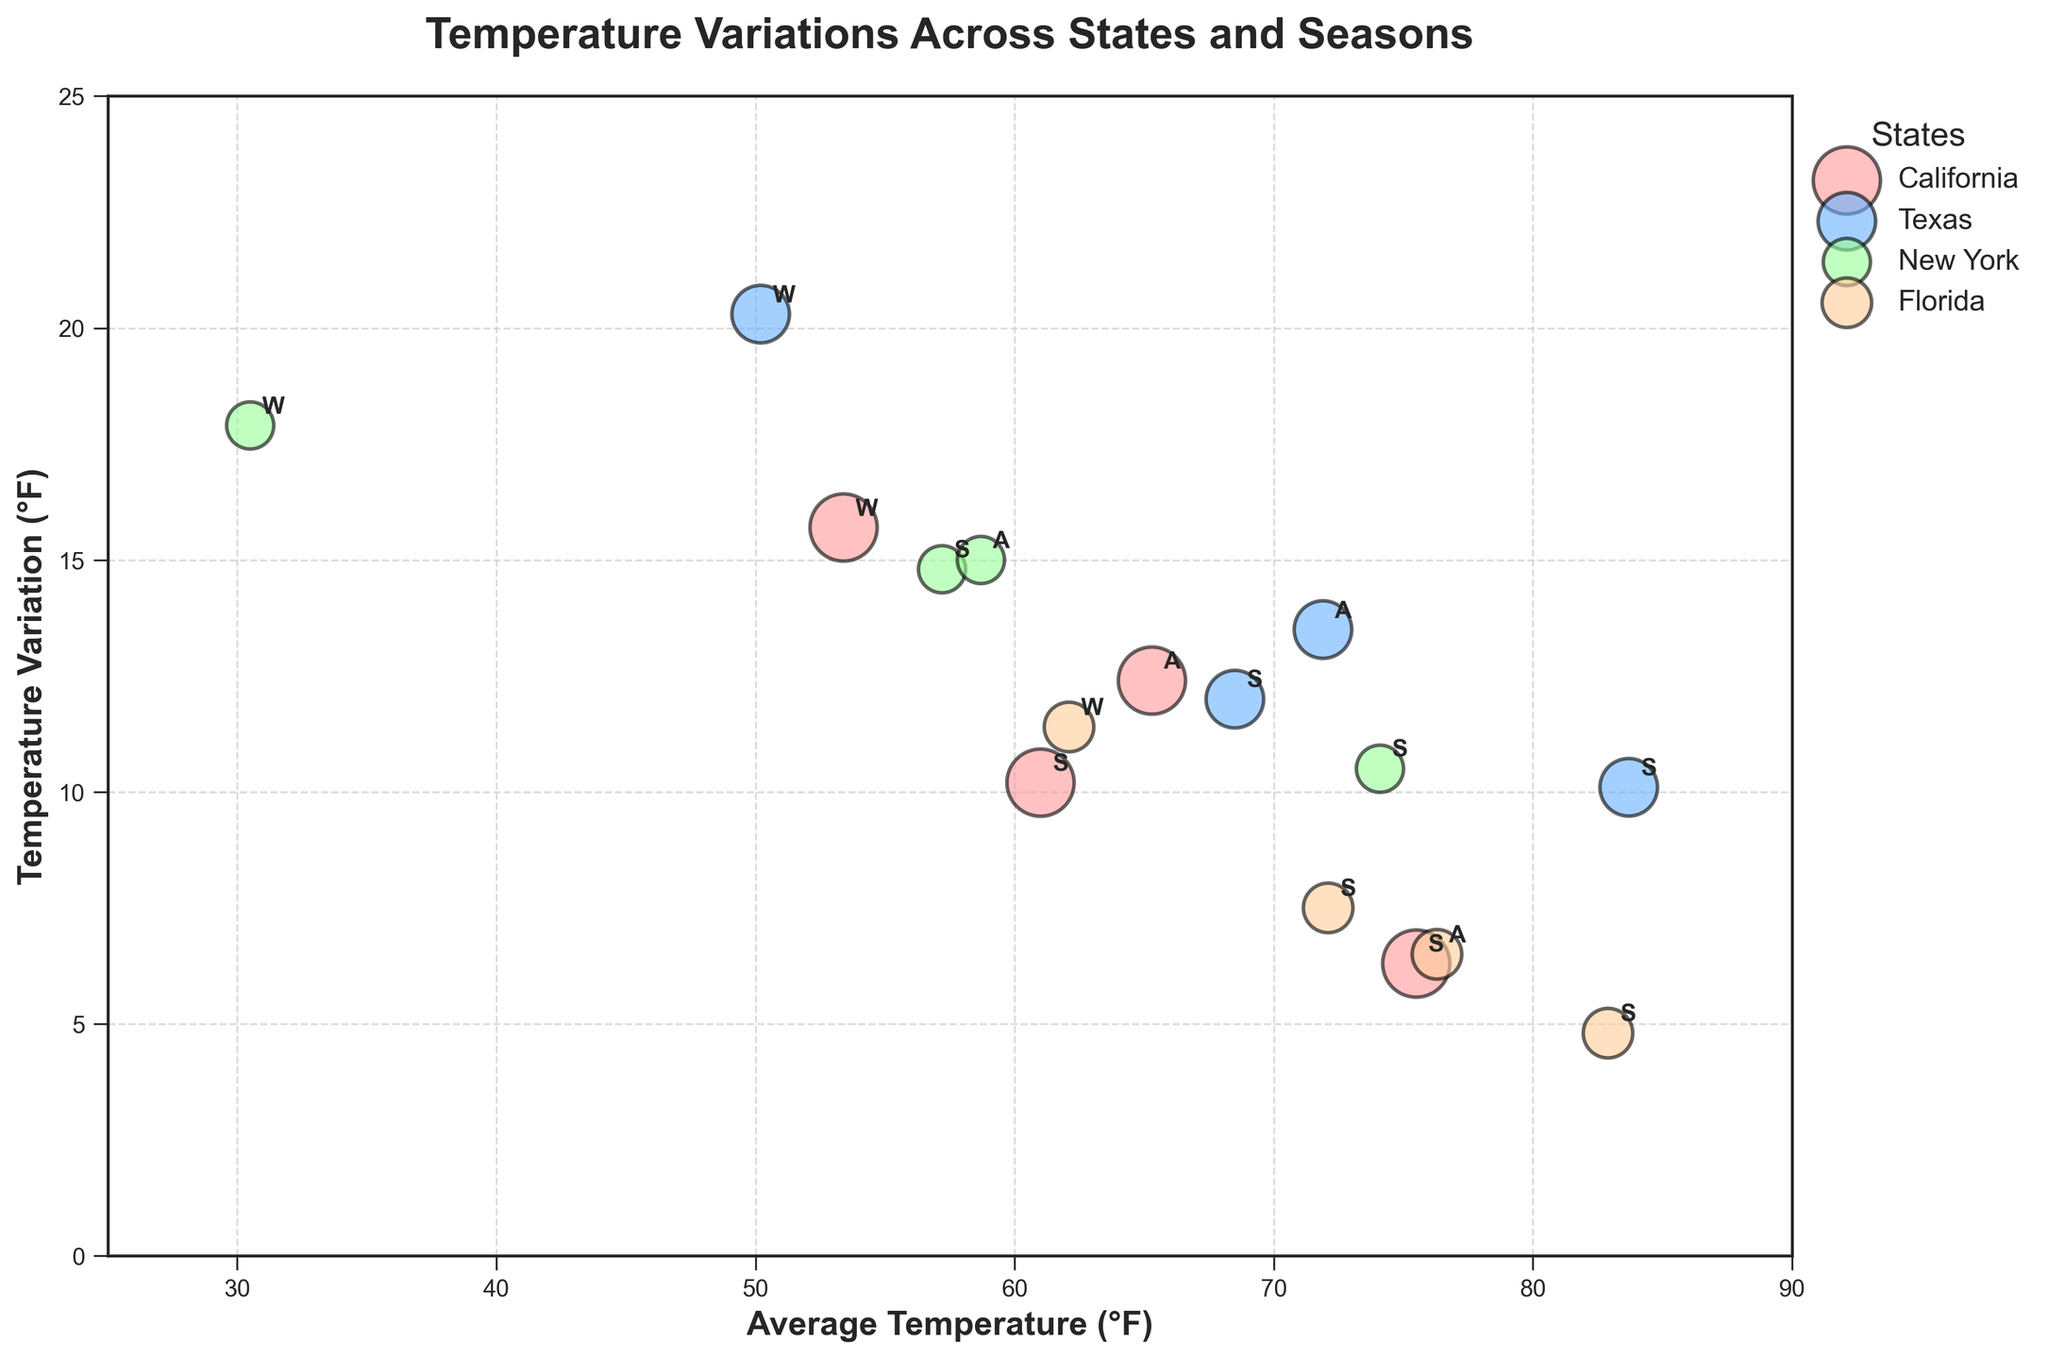What is the title of the figure? The title can usually be found at the top of the chart. In this case, it is clear from looking at the chart itself.
Answer: Temperature Variations Across States and Seasons What does the x-axis represent in the figure? The x-axis is labeled below the horizontal line at the bottom of the chart. This label specifies what the axis represents.
Answer: Average Temperature (°F) How many states are represented in the figure? Each state is represented by bubbles of different colors. You can refer to the legend to count the number of different groups.
Answer: 4 Which season has the highest average temperature for New York? To answer, check the x-axis values of New York's labeled bubbles. Identify the highest x-axis value among the seasons.
Answer: Summer What is the temperature variation in Winter for Florida? Find the winter bubble for Florida and refer to the y-axis value corresponding to it.
Answer: 11.4 °F Between which states do we observe the largest difference in temperature variation during Winter? Compare the y-axis values of winter bubbles for each state. The largest difference will be found by subtracting the smallest y-axis value from the largest one.
Answer: Texas and Florida What is the average temperature difference between Summer and Winter for California? Identify the average temperatures for Summer and Winter for California from the x-axis. Subtract the Winter temperature from the Summer temperature.
Answer: 75.5 - 53.4 = 22.1 °F Which state shows the smallest variation in temperature during Summer? Examine the y-axis values of the Summer bubbles for each state. The smallest y-axis value indicates the smallest temperature variation.
Answer: Florida Between Texas and California, which state has a higher temperature variation in Autumn? Examine the Autumn bubbles for Texas and California. Compare their y-axis values and identify the higher one.
Answer: Texas What does the size of the bubbles represent in the figure? The size can be inferred from the legend or the bubbles' description. It typically corresponds to another variable listed.
Answer: Population (Millions) 